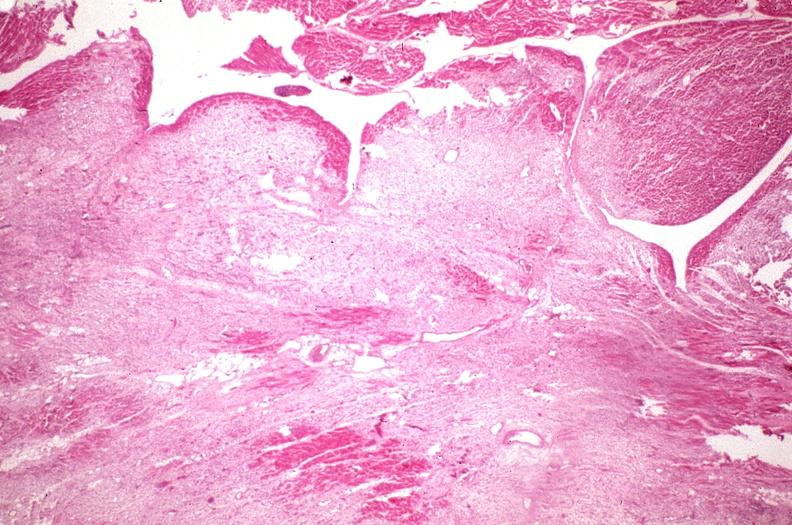s cardiovascular present?
Answer the question using a single word or phrase. Yes 